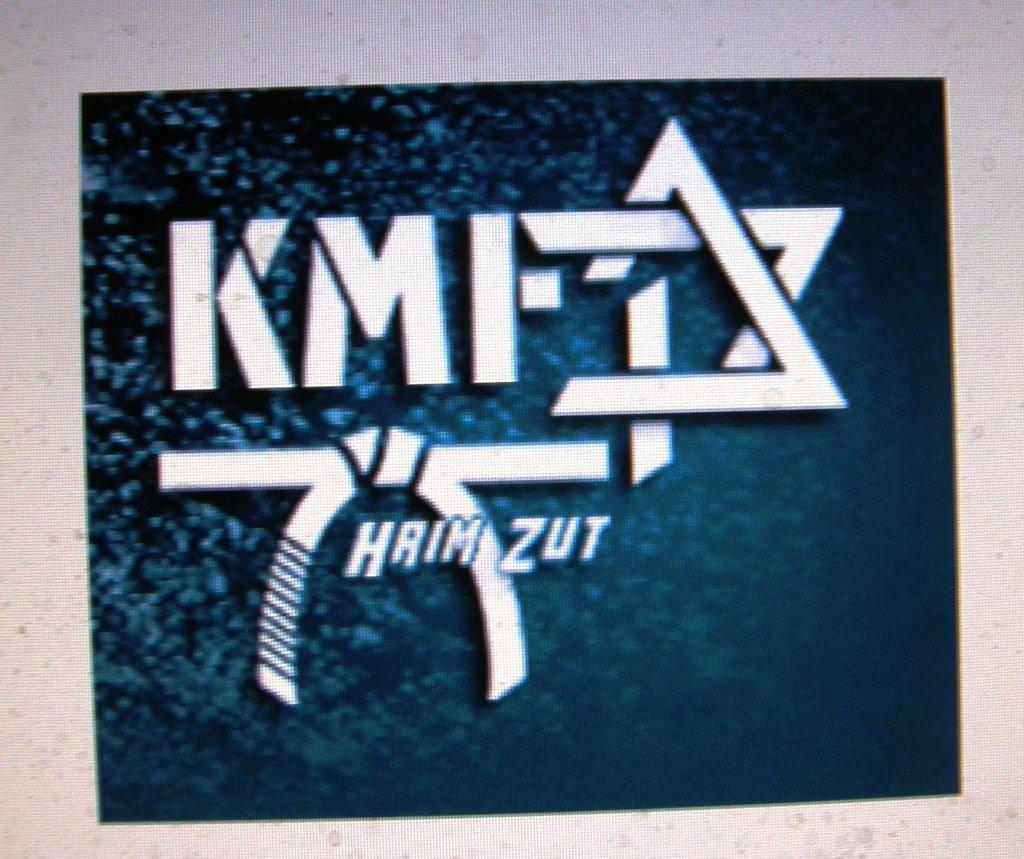What is present on the blue surface in the image? There is text on the blue surface in the image. Where is the text located on the blue surface? The text is located in the center of the image. How many pieces of coal can be seen on the blue surface in the image? There is no coal present in the image; it only features text on a blue surface. 